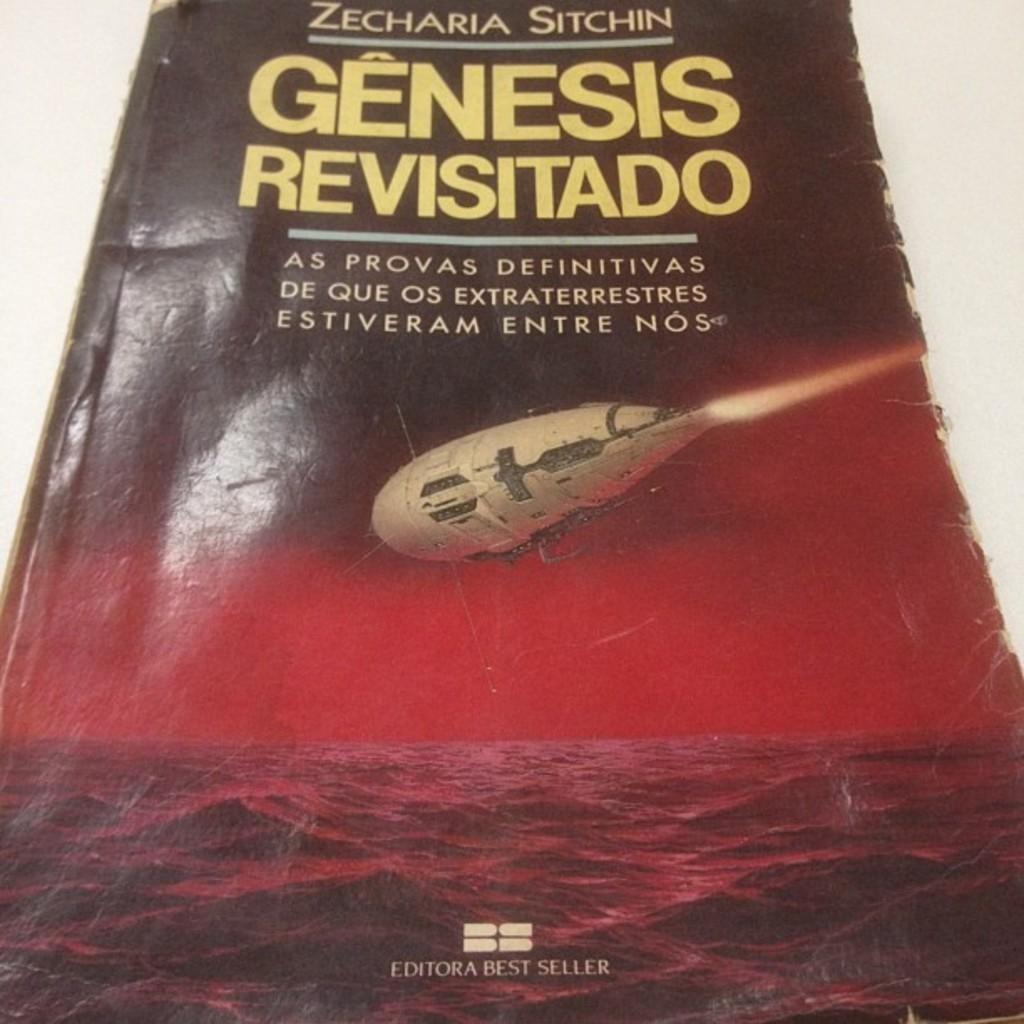<image>
Offer a succinct explanation of the picture presented. The book written by Zecharia Sitchin is titles Genensis Revisitado. 